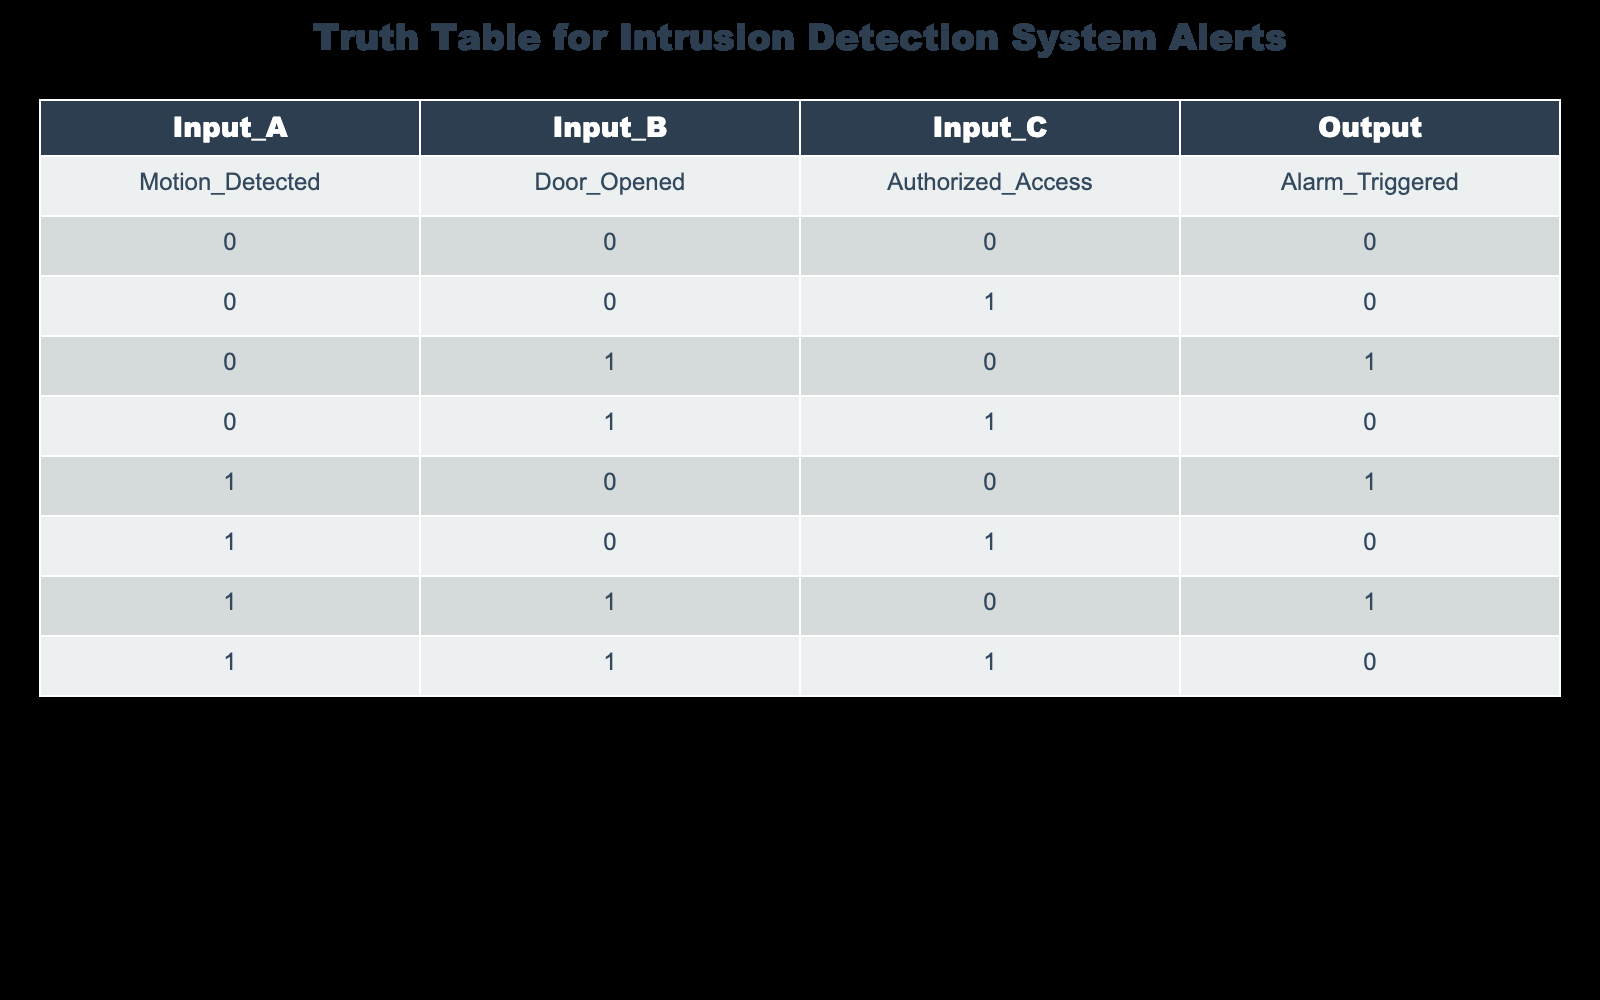What is the output when all inputs are zero? According to the table, when all inputs (Motion_Detected, Door_Opened, Authorized_Access) are zero (0, 0, 0), the Output (Alarm_Triggered) is also zero (0).
Answer: 0 What is the output when the door is opened and access is unauthorized? From the table, when Door_Opened is 1 and Authorized_Access is 0 with Motion_Detected being 0 (Input_B = 1, Input_A = 0, Input_C = 0), the Output shows Alarm_Triggered is 1.
Answer: 1 How many conditions lead to an alarm being triggered? By examining the table, the rows where Alarm_Triggered is 1 are present for the following inputs: (0, 1, 0), (1, 0, 0), and (1, 1, 0). So, there are three conditions that trigger the alarm.
Answer: 3 Is it true that an alarm is triggered when motion is detected and the door is opened regardless of access? Looking at the rows where Motion_Detected (1) and Door_Opened (1) are both true, there are two scenarios: one where Authorized_Access is 0 (Output is 1) and one where it's 1 (Output is 0). Thus, the statement is false as it doesn't consistently trigger the alarm.
Answer: No What is the output when motion is detected and access is authorized? When Motion_Detected is 1 and Authorized_Access is 1 (with Input_B = 0), the Output in the table shows Alarm_Triggered is 0. Hence, the system does not trigger the alarm.
Answer: 0 Under what combination of inputs is the alarm not triggered? The table shows that the alarms are not triggered in the following scenarios: (0, 0, 0), (0, 1, 1), (1, 0, 1), and (1, 1, 1). Thus, these four combinations result in no alarm being activated.
Answer: 4 If there is motion detected, what is the likelihood of the alarm being triggered? In the cases where Motion_Detected is 1 (three scenarios), the output is 1 for two cases (when Door_Opened is 0) and 0 for one case (when both Door_Opened and Authorized_Access are 1). Thus, the likelihood of an alarm being triggered given that motion is detected is 2 out of 3.
Answer: 67% Is the output always triggered when the door is opened? Analyzing the cases where Door_Opened is 1, we can see the output is 1 for one case (0, 1, 0) but is 0 for another (1, 1, 1). Therefore, the output does not trigger in every scenario when the door is opened.
Answer: No 